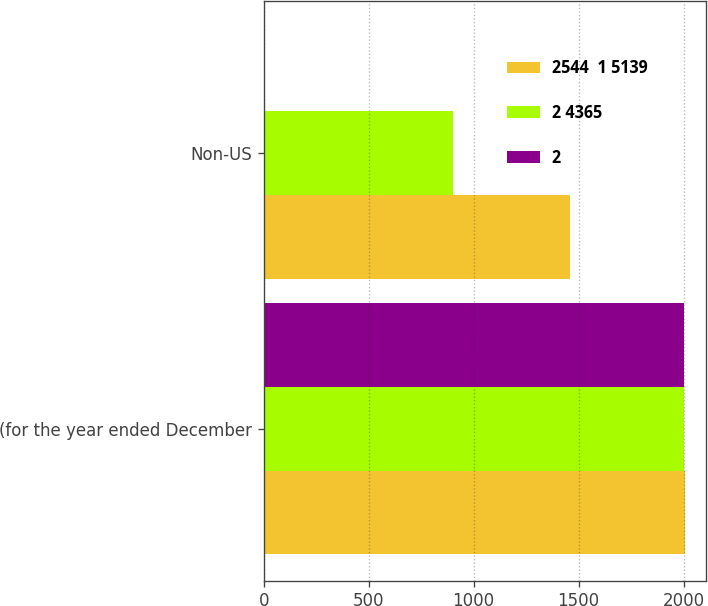Convert chart. <chart><loc_0><loc_0><loc_500><loc_500><stacked_bar_chart><ecel><fcel>(for the year ended December<fcel>Non-US<nl><fcel>2544  1 5139<fcel>2005<fcel>1457<nl><fcel>2 4365<fcel>2004<fcel>904<nl><fcel>2<fcel>2003<fcel>6<nl></chart> 